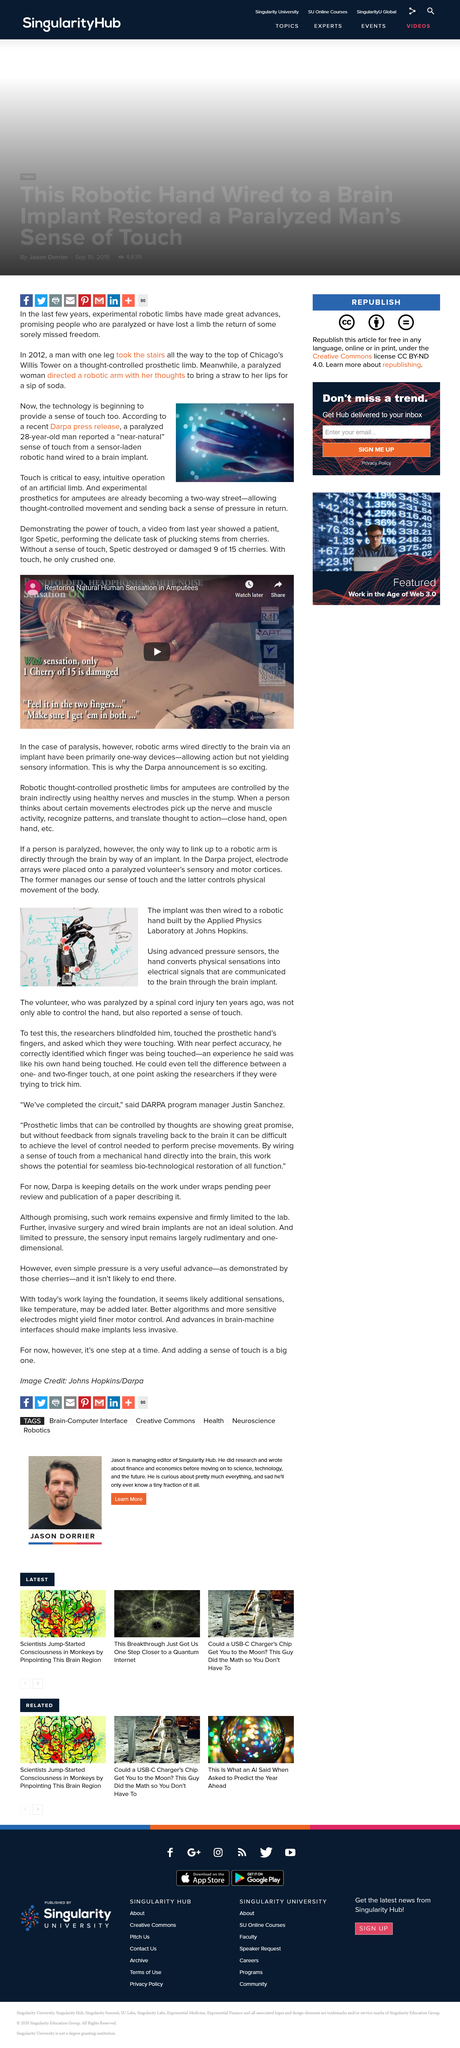Specify some key components in this picture. It is scientifically established that the only way to link up a robotic arm is directly through the brain by way of an implant. In recent years, there have been significant advancements in experimental robotic limbs, as evidenced by the successful ascent of a man with one leg to the top of Chicago's Willis Tower using a thought-controlled prosthetic limb in 2012. The volunteer reported controlling the hand and experiencing a sense of touch. Touch is essential to the easy and intuitive operation of an artificial limb. The robotic arm was constructed by the Applied Physics Laboratory at Johns Hopkins University. 